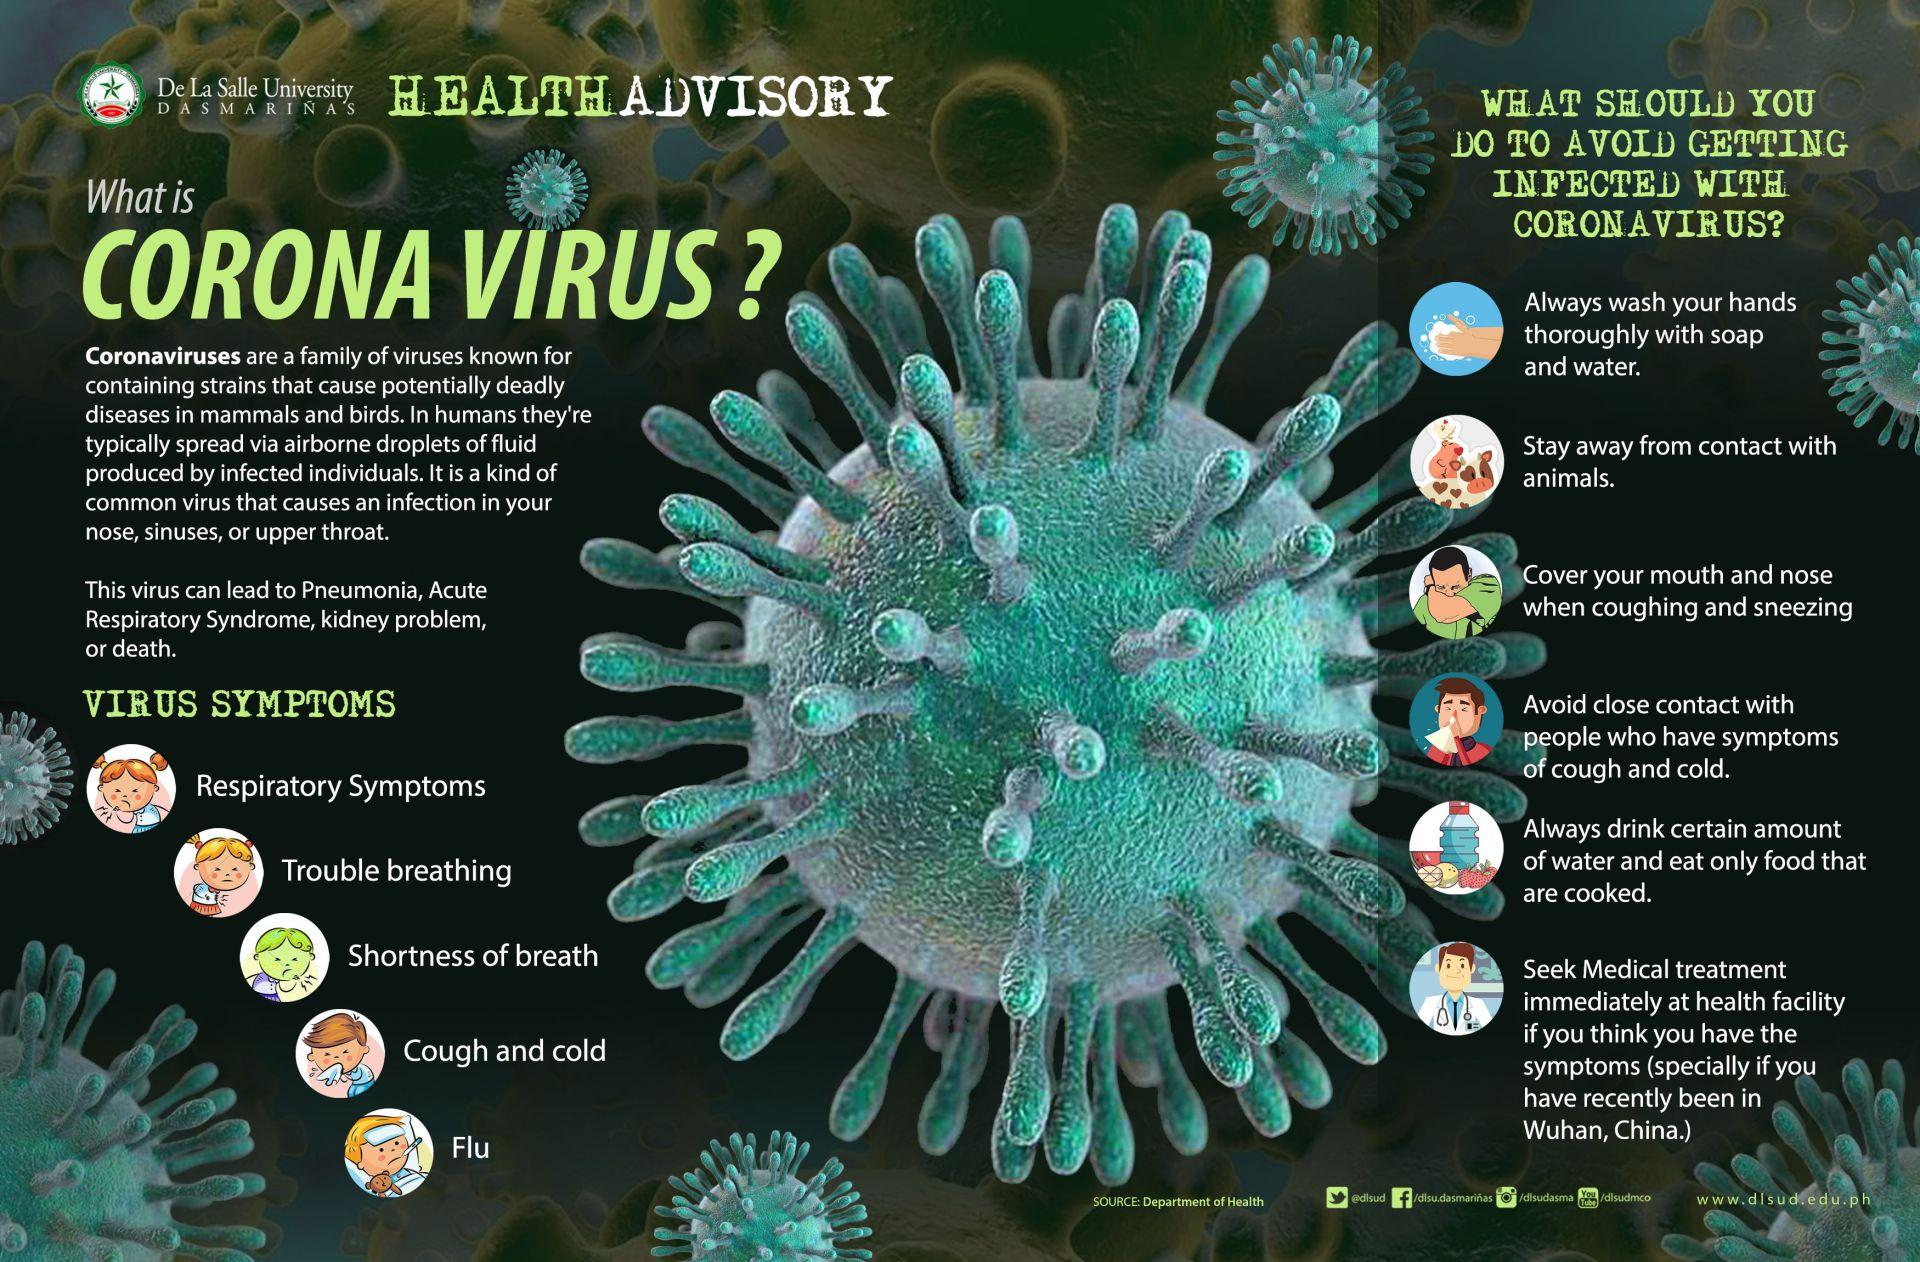Highlight a few significant elements in this photo. There are five symptoms in this infographic. The second symptom in the infographic is difficulty breathing. The fifth symptom in the infographic is flu. There are 6 points listed under the heading "What should you do to avoid getting infected with coronavirus? The third symptom in the infographic is shortness of breath. 